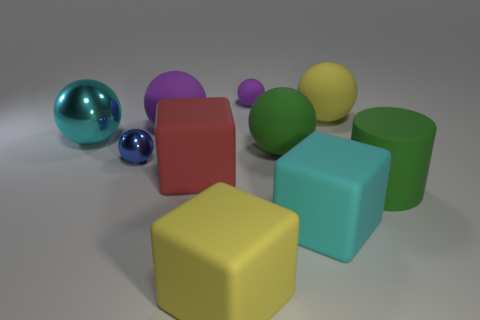Subtract all red cylinders. How many purple spheres are left? 2 Subtract all small purple spheres. How many spheres are left? 5 Subtract all green balls. How many balls are left? 5 Subtract all red spheres. Subtract all green cylinders. How many spheres are left? 6 Subtract all cubes. How many objects are left? 7 Add 1 small things. How many small things are left? 3 Add 7 cyan metallic cylinders. How many cyan metallic cylinders exist? 7 Subtract 0 brown spheres. How many objects are left? 10 Subtract all green metal cylinders. Subtract all large yellow objects. How many objects are left? 8 